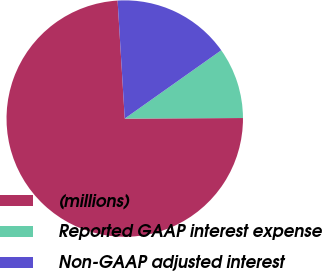<chart> <loc_0><loc_0><loc_500><loc_500><pie_chart><fcel>(millions)<fcel>Reported GAAP interest expense<fcel>Non-GAAP adjusted interest<nl><fcel>74.11%<fcel>9.73%<fcel>16.16%<nl></chart> 